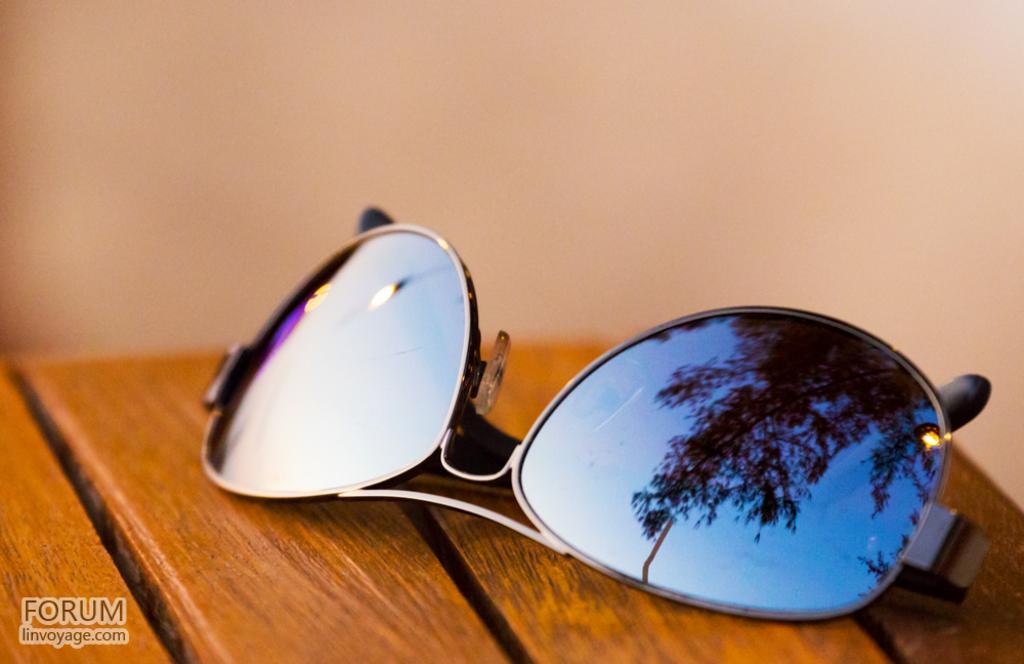In one or two sentences, can you explain what this image depicts? In the foreground of the picture there is a table, on the table there are goggles. The background is blurred. 